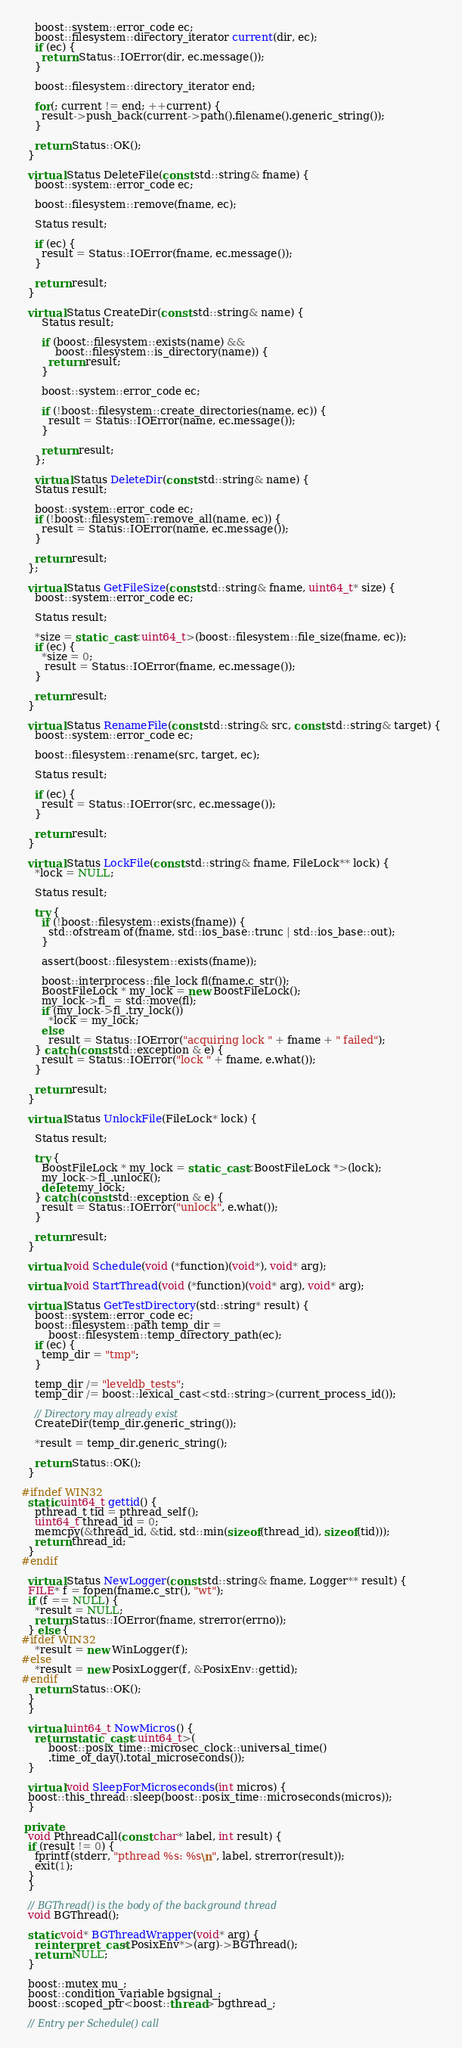Convert code to text. <code><loc_0><loc_0><loc_500><loc_500><_C++_>    boost::system::error_code ec;
    boost::filesystem::directory_iterator current(dir, ec);
    if (ec) {
      return Status::IOError(dir, ec.message());
    }

    boost::filesystem::directory_iterator end;

    for(; current != end; ++current) {
      result->push_back(current->path().filename().generic_string());
    }

    return Status::OK();
  }

  virtual Status DeleteFile(const std::string& fname) {
    boost::system::error_code ec;

    boost::filesystem::remove(fname, ec);

    Status result;

    if (ec) {
      result = Status::IOError(fname, ec.message());
    }

    return result;
  }

  virtual Status CreateDir(const std::string& name) {
      Status result;

      if (boost::filesystem::exists(name) &&
          boost::filesystem::is_directory(name)) {
        return result;
      }

      boost::system::error_code ec;

      if (!boost::filesystem::create_directories(name, ec)) {
        result = Status::IOError(name, ec.message());
      }

      return result;
    };

    virtual Status DeleteDir(const std::string& name) {
    Status result;

    boost::system::error_code ec;
    if (!boost::filesystem::remove_all(name, ec)) {
      result = Status::IOError(name, ec.message());
    }

    return result;
  };

  virtual Status GetFileSize(const std::string& fname, uint64_t* size) {
    boost::system::error_code ec;

    Status result;

    *size = static_cast<uint64_t>(boost::filesystem::file_size(fname, ec));
    if (ec) {
      *size = 0;
       result = Status::IOError(fname, ec.message());
    }

    return result;
  }

  virtual Status RenameFile(const std::string& src, const std::string& target) {
    boost::system::error_code ec;

    boost::filesystem::rename(src, target, ec);

    Status result;

    if (ec) {
      result = Status::IOError(src, ec.message());
    }

    return result;
  }

  virtual Status LockFile(const std::string& fname, FileLock** lock) {
    *lock = NULL;

    Status result;

    try {
      if (!boost::filesystem::exists(fname)) {
        std::ofstream of(fname, std::ios_base::trunc | std::ios_base::out);
      }

      assert(boost::filesystem::exists(fname));

      boost::interprocess::file_lock fl(fname.c_str());
      BoostFileLock * my_lock = new BoostFileLock();
      my_lock->fl_ = std::move(fl);
      if (my_lock->fl_.try_lock())
        *lock = my_lock;
      else
        result = Status::IOError("acquiring lock " + fname + " failed");
    } catch (const std::exception & e) {
      result = Status::IOError("lock " + fname, e.what());
    }

    return result;
  }

  virtual Status UnlockFile(FileLock* lock) {

    Status result;

    try {
      BoostFileLock * my_lock = static_cast<BoostFileLock *>(lock);
      my_lock->fl_.unlock();
      delete my_lock;
    } catch (const std::exception & e) {
      result = Status::IOError("unlock", e.what());
    }

    return result;
  }

  virtual void Schedule(void (*function)(void*), void* arg);

  virtual void StartThread(void (*function)(void* arg), void* arg);

  virtual Status GetTestDirectory(std::string* result) {
    boost::system::error_code ec;
    boost::filesystem::path temp_dir = 
        boost::filesystem::temp_directory_path(ec);
    if (ec) {
      temp_dir = "tmp";
    }

    temp_dir /= "leveldb_tests";
    temp_dir /= boost::lexical_cast<std::string>(current_process_id());

    // Directory may already exist
    CreateDir(temp_dir.generic_string());

    *result = temp_dir.generic_string();

    return Status::OK();
  }

#ifndef WIN32
  static uint64_t gettid() {
    pthread_t tid = pthread_self();
    uint64_t thread_id = 0;
    memcpy(&thread_id, &tid, std::min(sizeof(thread_id), sizeof(tid)));
    return thread_id;
  }
#endif

  virtual Status NewLogger(const std::string& fname, Logger** result) {
  FILE* f = fopen(fname.c_str(), "wt");
  if (f == NULL) {
    *result = NULL;
    return Status::IOError(fname, strerror(errno));
  } else {
#ifdef WIN32
    *result = new WinLogger(f);
#else
    *result = new PosixLogger(f, &PosixEnv::gettid);
#endif
    return Status::OK();
  }
  }

  virtual uint64_t NowMicros() {
    return static_cast<uint64_t>(
        boost::posix_time::microsec_clock::universal_time()
        .time_of_day().total_microseconds());
  }

  virtual void SleepForMicroseconds(int micros) {
  boost::this_thread::sleep(boost::posix_time::microseconds(micros));
  }

 private:
  void PthreadCall(const char* label, int result) {
  if (result != 0) {
    fprintf(stderr, "pthread %s: %s\n", label, strerror(result));
    exit(1);
  }
  }

  // BGThread() is the body of the background thread
  void BGThread();

  static void* BGThreadWrapper(void* arg) {
    reinterpret_cast<PosixEnv*>(arg)->BGThread();
    return NULL;
  }

  boost::mutex mu_;
  boost::condition_variable bgsignal_;
  boost::scoped_ptr<boost::thread> bgthread_;

  // Entry per Schedule() call</code> 